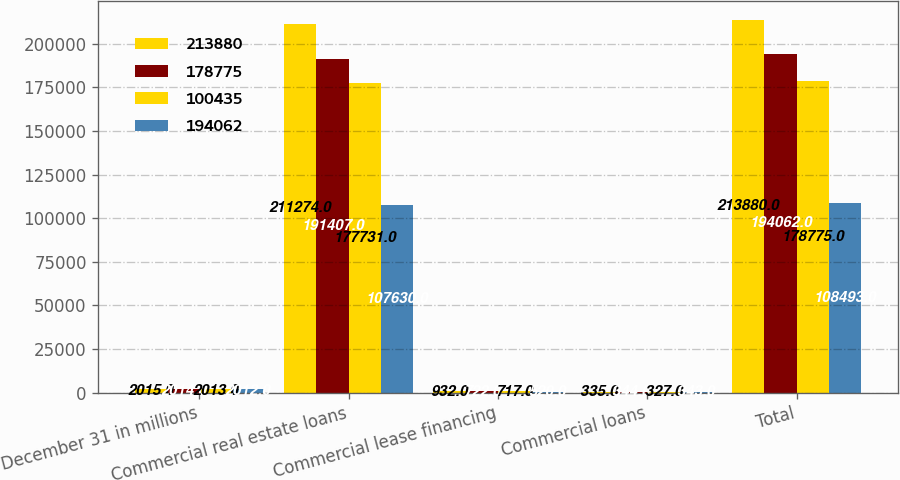Convert chart to OTSL. <chart><loc_0><loc_0><loc_500><loc_500><stacked_bar_chart><ecel><fcel>December 31 in millions<fcel>Commercial real estate loans<fcel>Commercial lease financing<fcel>Commercial loans<fcel>Total<nl><fcel>213880<fcel>2015<fcel>211274<fcel>932<fcel>335<fcel>213880<nl><fcel>178775<fcel>2014<fcel>191407<fcel>722<fcel>344<fcel>194062<nl><fcel>100435<fcel>2013<fcel>177731<fcel>717<fcel>327<fcel>178775<nl><fcel>194062<fcel>2012<fcel>107630<fcel>520<fcel>343<fcel>108493<nl></chart> 